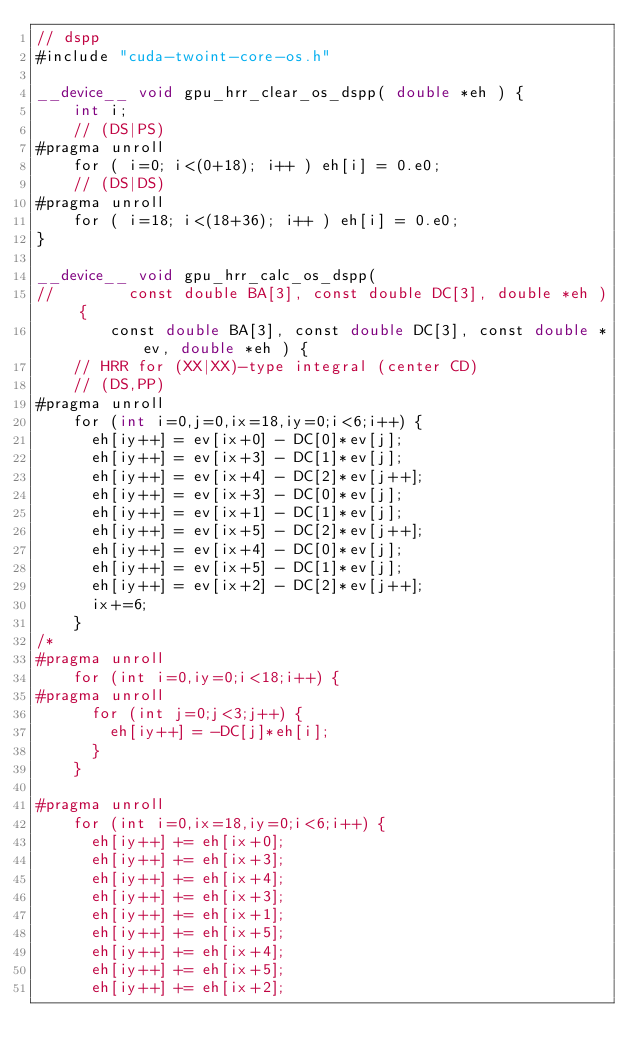Convert code to text. <code><loc_0><loc_0><loc_500><loc_500><_Cuda_>// dspp
#include "cuda-twoint-core-os.h"

__device__ void gpu_hrr_clear_os_dspp( double *eh ) {
    int i;
    // (DS|PS)
#pragma unroll
    for ( i=0; i<(0+18); i++ ) eh[i] = 0.e0;
    // (DS|DS)
#pragma unroll
    for ( i=18; i<(18+36); i++ ) eh[i] = 0.e0;
}

__device__ void gpu_hrr_calc_os_dspp(
//        const double BA[3], const double DC[3], double *eh ) {
        const double BA[3], const double DC[3], const double *ev, double *eh ) {
    // HRR for (XX|XX)-type integral (center CD)
    // (DS,PP)
#pragma unroll
    for (int i=0,j=0,ix=18,iy=0;i<6;i++) {
      eh[iy++] = ev[ix+0] - DC[0]*ev[j];
      eh[iy++] = ev[ix+3] - DC[1]*ev[j];
      eh[iy++] = ev[ix+4] - DC[2]*ev[j++];
      eh[iy++] = ev[ix+3] - DC[0]*ev[j];
      eh[iy++] = ev[ix+1] - DC[1]*ev[j];
      eh[iy++] = ev[ix+5] - DC[2]*ev[j++];
      eh[iy++] = ev[ix+4] - DC[0]*ev[j];
      eh[iy++] = ev[ix+5] - DC[1]*ev[j];
      eh[iy++] = ev[ix+2] - DC[2]*ev[j++];
      ix+=6;
    }
/*
#pragma unroll
    for (int i=0,iy=0;i<18;i++) {
#pragma unroll
      for (int j=0;j<3;j++) {
        eh[iy++] = -DC[j]*eh[i];
      }
    }

#pragma unroll
    for (int i=0,ix=18,iy=0;i<6;i++) {
      eh[iy++] += eh[ix+0];
      eh[iy++] += eh[ix+3];
      eh[iy++] += eh[ix+4];
      eh[iy++] += eh[ix+3];
      eh[iy++] += eh[ix+1];
      eh[iy++] += eh[ix+5];
      eh[iy++] += eh[ix+4];
      eh[iy++] += eh[ix+5];
      eh[iy++] += eh[ix+2];</code> 